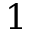Convert formula to latex. <formula><loc_0><loc_0><loc_500><loc_500>1</formula> 